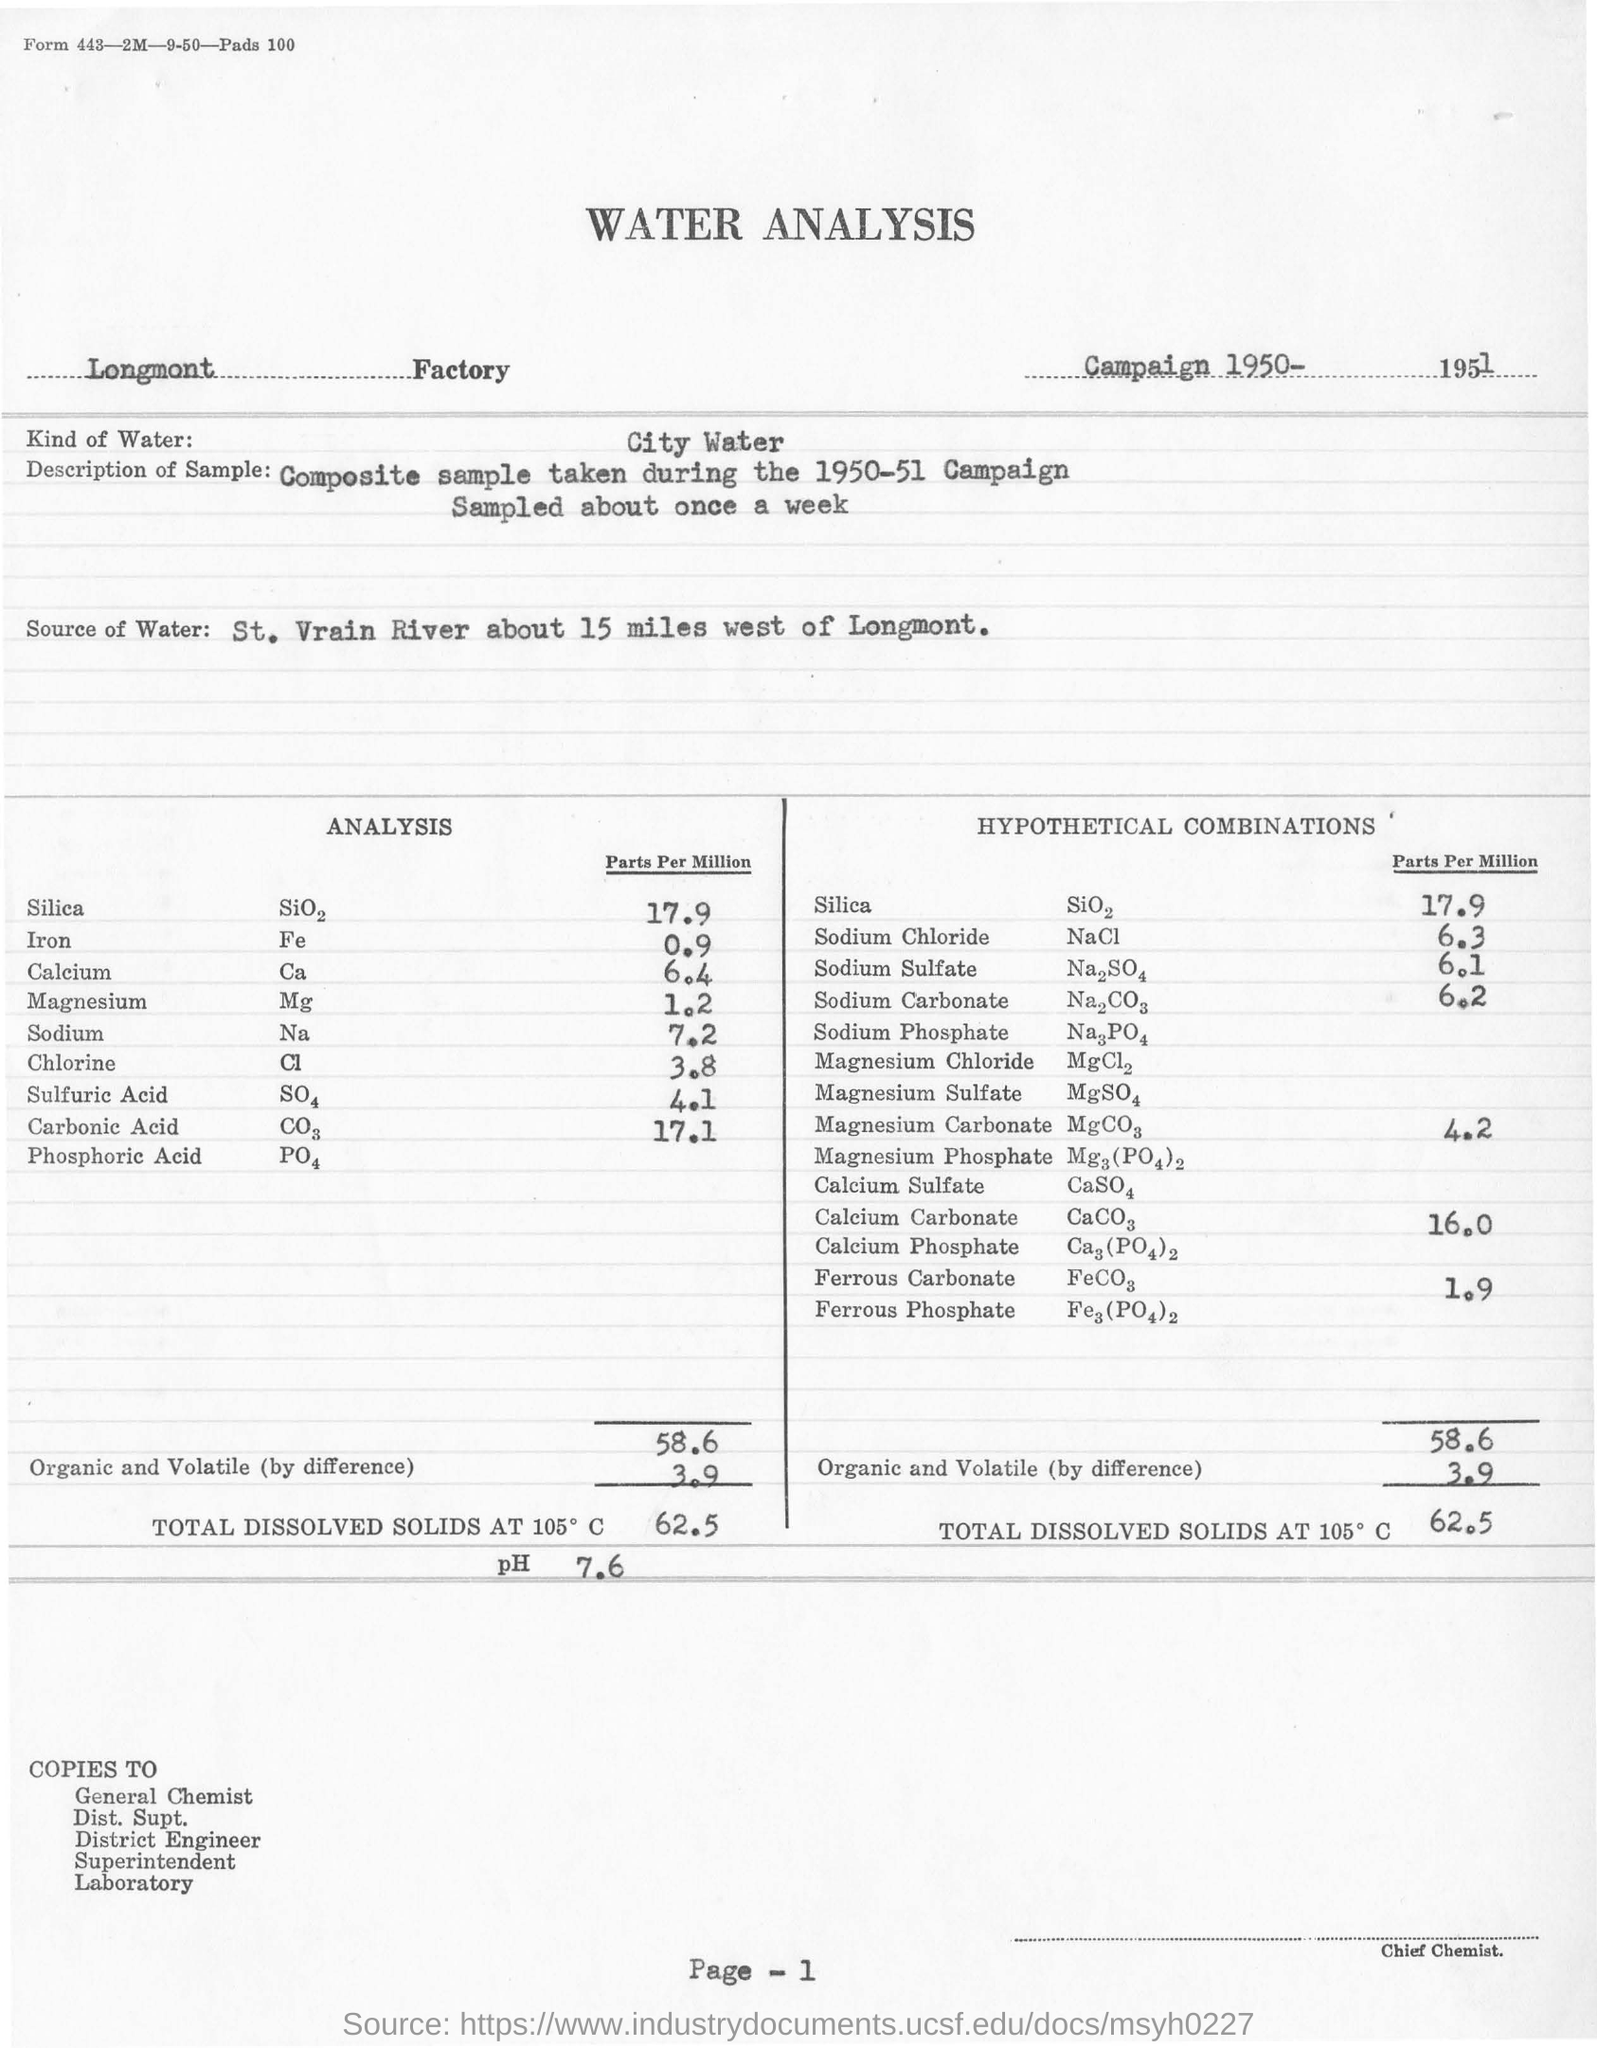Mention a couple of crucial points in this snapshot. The pH was 7.6. The water analysis was conducted in a factory located in Longmont. The analysis involved city water. The campaign took place in the year 1950-51. The St. Vrain River was the source of the water. 